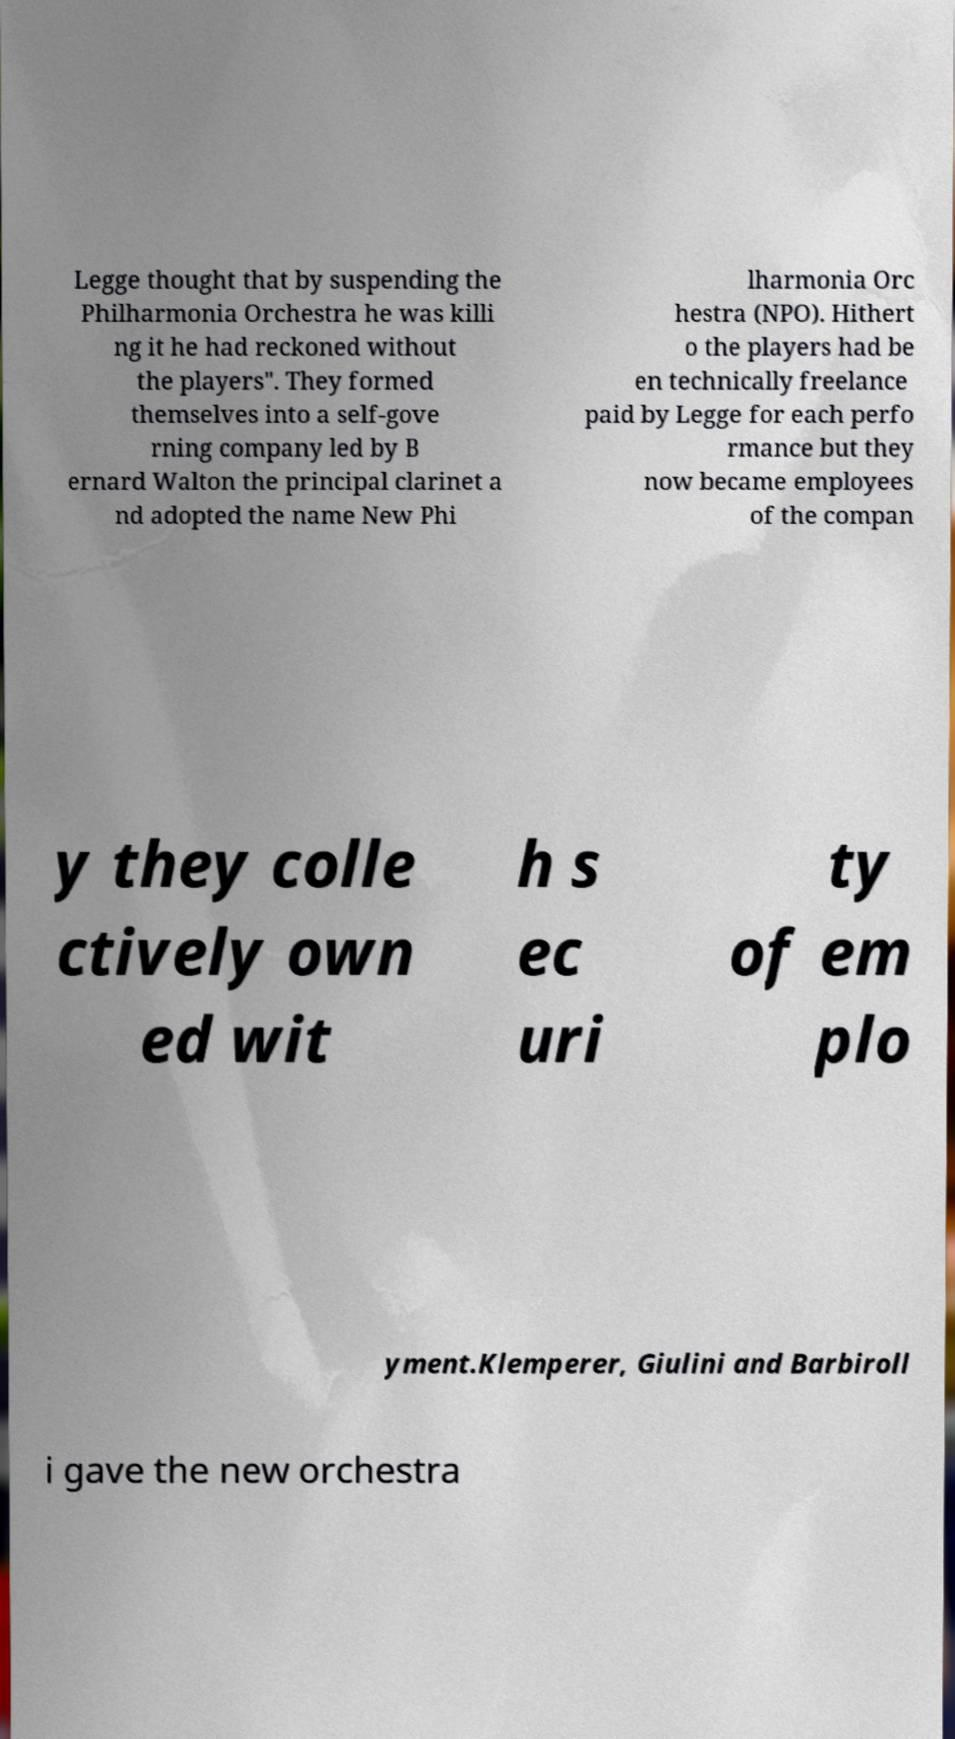Could you extract and type out the text from this image? Legge thought that by suspending the Philharmonia Orchestra he was killi ng it he had reckoned without the players". They formed themselves into a self-gove rning company led by B ernard Walton the principal clarinet a nd adopted the name New Phi lharmonia Orc hestra (NPO). Hithert o the players had be en technically freelance paid by Legge for each perfo rmance but they now became employees of the compan y they colle ctively own ed wit h s ec uri ty of em plo yment.Klemperer, Giulini and Barbiroll i gave the new orchestra 